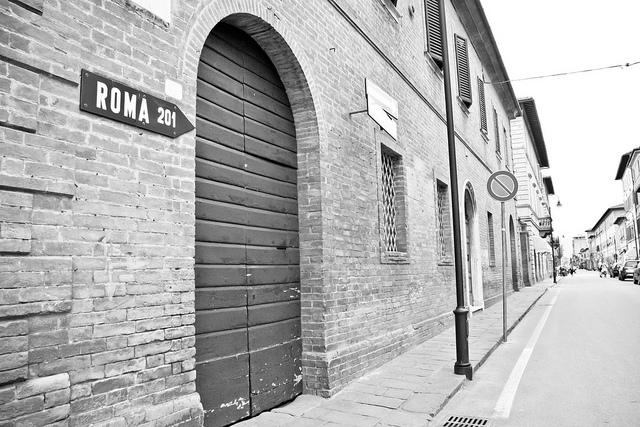What place is this most likely?

Choices:
A) new jersey
B) new york
C) rome
D) china rome 